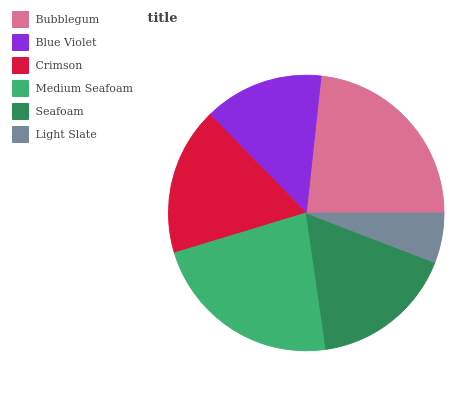Is Light Slate the minimum?
Answer yes or no. Yes. Is Bubblegum the maximum?
Answer yes or no. Yes. Is Blue Violet the minimum?
Answer yes or no. No. Is Blue Violet the maximum?
Answer yes or no. No. Is Bubblegum greater than Blue Violet?
Answer yes or no. Yes. Is Blue Violet less than Bubblegum?
Answer yes or no. Yes. Is Blue Violet greater than Bubblegum?
Answer yes or no. No. Is Bubblegum less than Blue Violet?
Answer yes or no. No. Is Crimson the high median?
Answer yes or no. Yes. Is Seafoam the low median?
Answer yes or no. Yes. Is Light Slate the high median?
Answer yes or no. No. Is Blue Violet the low median?
Answer yes or no. No. 